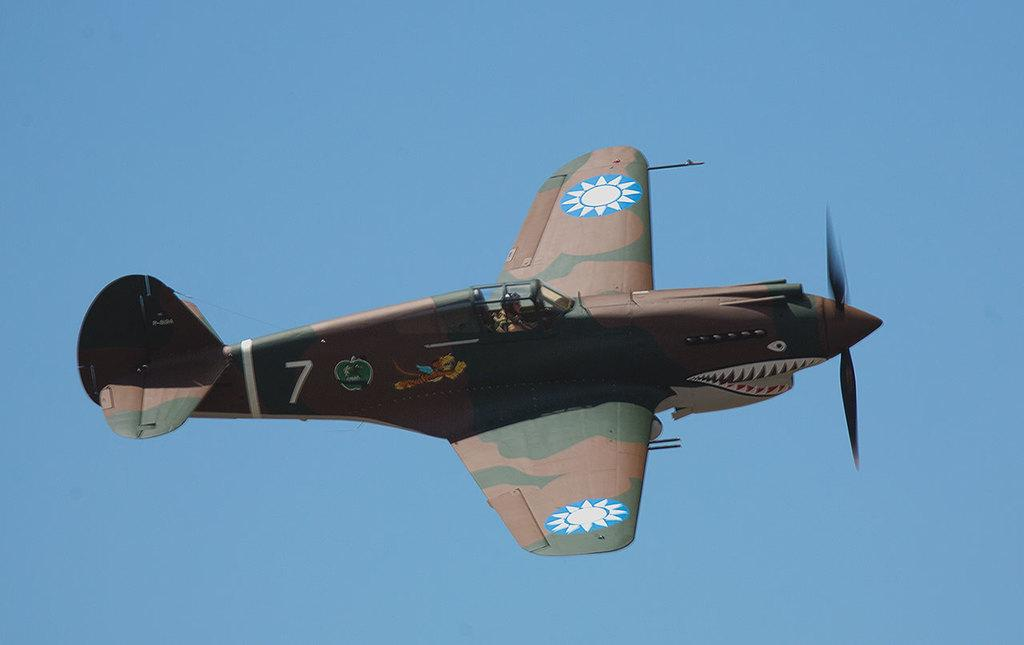Where was the image taken? The image was clicked outside the city. What can be seen in the sky in the image? There is an aircraft flying in the sky. What is visible in the background of the image? The sky is visible in the background of the image. What type of texture can be seen on the trousers in the image? There are no trousers present in the image, so it is not possible to determine the texture. 